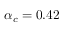<formula> <loc_0><loc_0><loc_500><loc_500>\alpha _ { c } = 0 . 4 2</formula> 